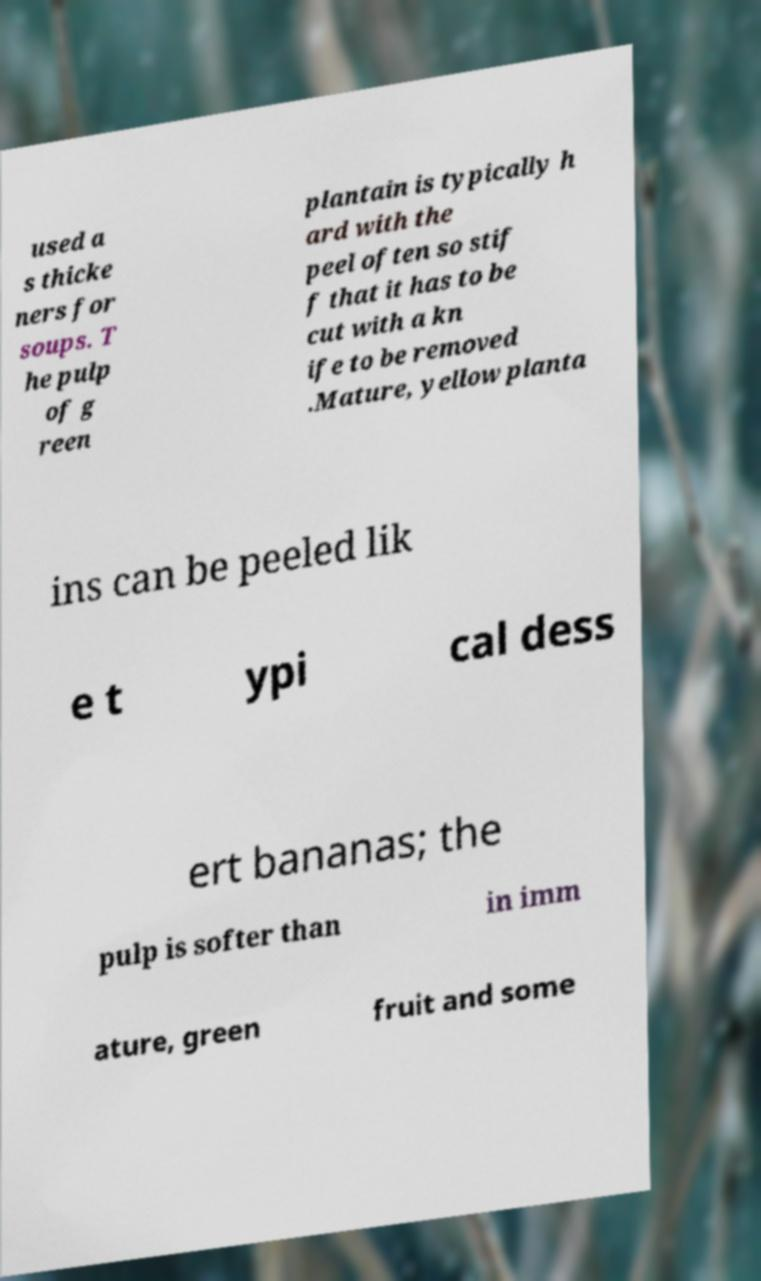I need the written content from this picture converted into text. Can you do that? used a s thicke ners for soups. T he pulp of g reen plantain is typically h ard with the peel often so stif f that it has to be cut with a kn ife to be removed .Mature, yellow planta ins can be peeled lik e t ypi cal dess ert bananas; the pulp is softer than in imm ature, green fruit and some 